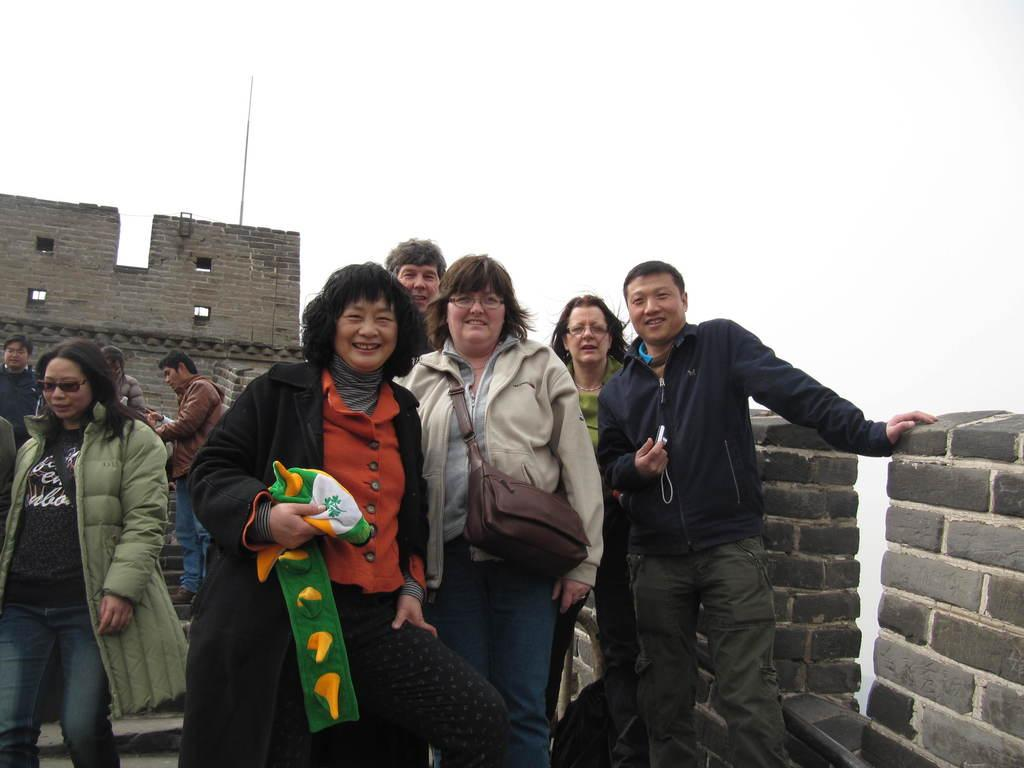How many people are in the image? There are people in the image, but the exact number is not specified. What are the people wearing in the image? The people are wearing coats in the image. Are any people carrying bags in the image? Yes, some people are wearing bags in the image. What are the people holding in the image? The people are holding objects in the image. What can be seen in the background of the image? There is a wall in the background of the image. What is visible at the top of the image? The sky is visible at the top of the image. What type of horse can be seen eating breakfast in the image? There is no horse or breakfast present in the image. Is there any leather visible in the image? There is no mention of leather in the provided facts, so it cannot be determined if it is present in the image. 